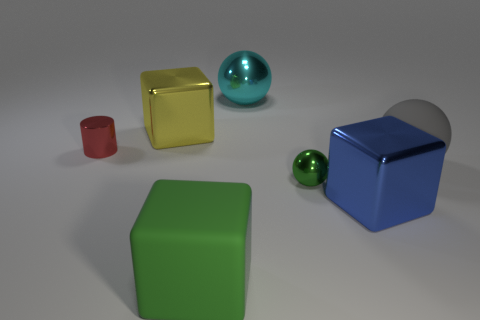Is there any other thing of the same color as the big matte block? Yes, there appears to be a small sphere that has a matching color to the big matte block, thus providing an example of recurring colors within the objects displayed. 